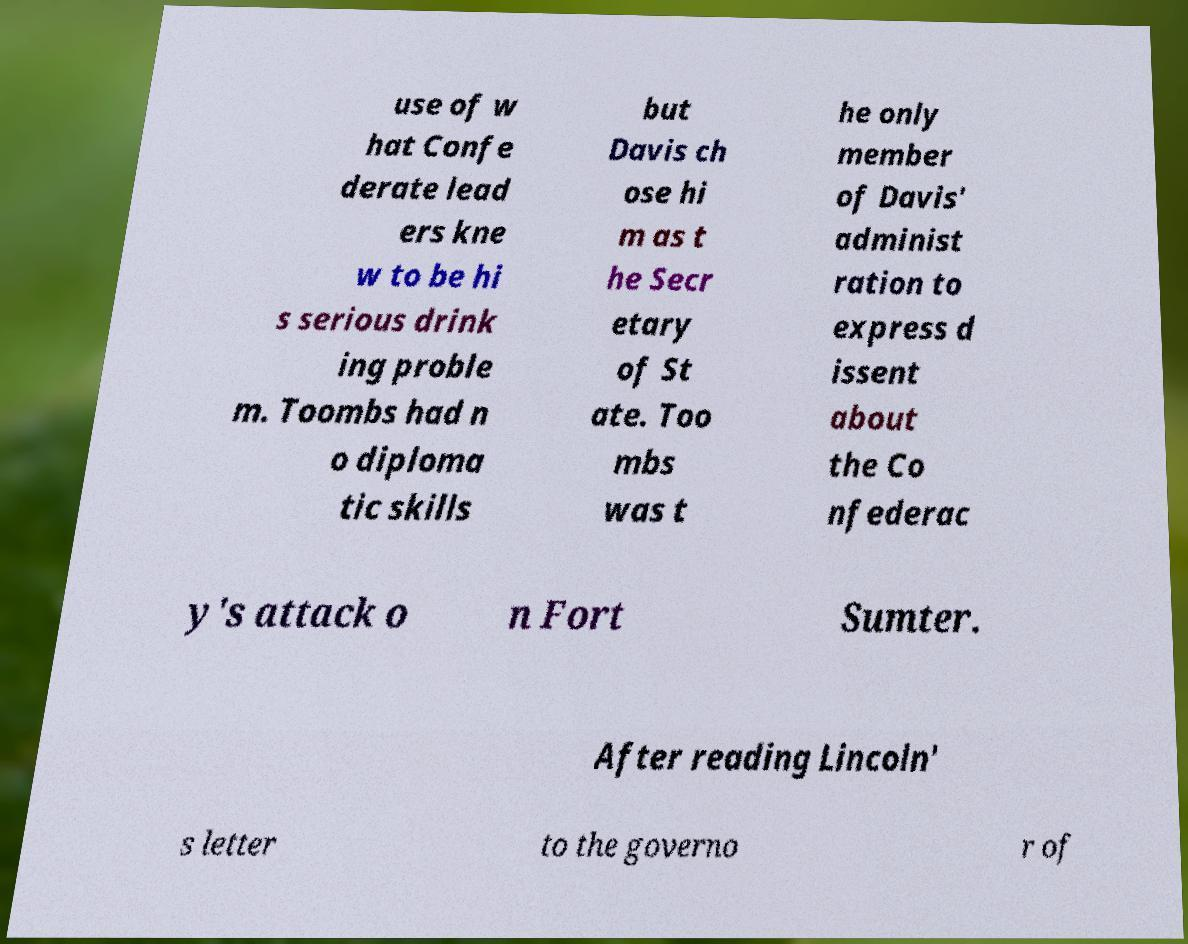Can you accurately transcribe the text from the provided image for me? use of w hat Confe derate lead ers kne w to be hi s serious drink ing proble m. Toombs had n o diploma tic skills but Davis ch ose hi m as t he Secr etary of St ate. Too mbs was t he only member of Davis' administ ration to express d issent about the Co nfederac y's attack o n Fort Sumter. After reading Lincoln' s letter to the governo r of 